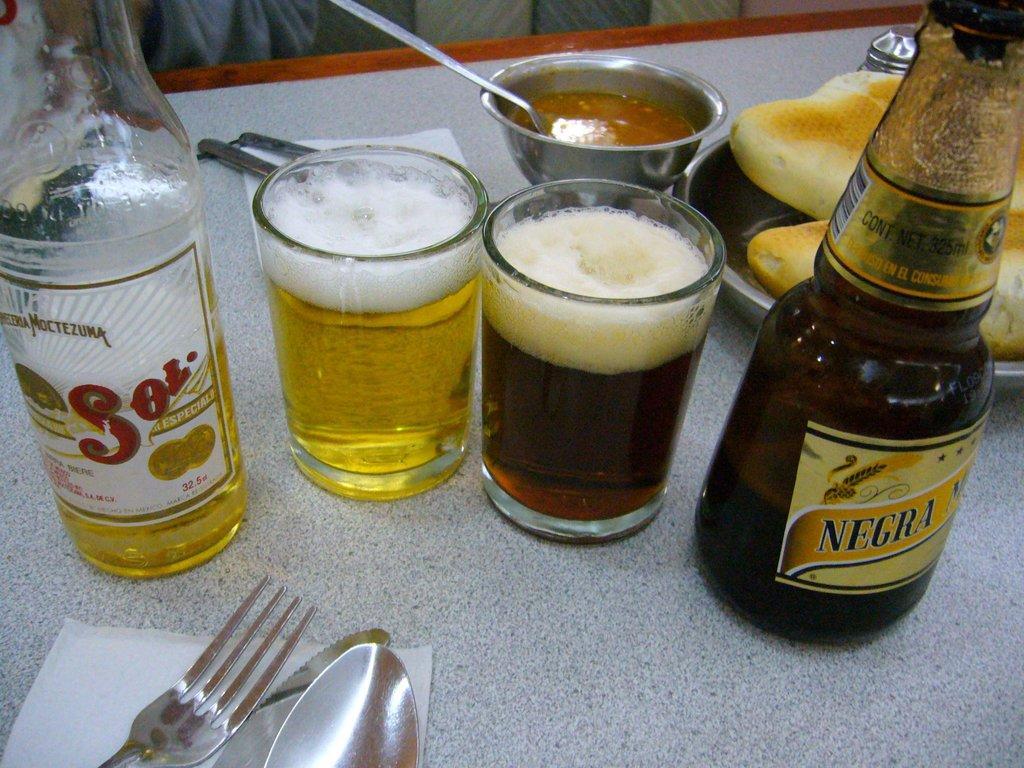Could you give a brief overview of what you see in this image? In this picture we can see bottles and glasses with drinks in it, fork, spoon, bowl, plate with food items on it, tissue paper and these all are placed on a table. 